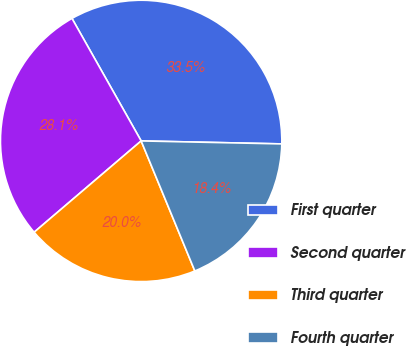Convert chart to OTSL. <chart><loc_0><loc_0><loc_500><loc_500><pie_chart><fcel>First quarter<fcel>Second quarter<fcel>Third quarter<fcel>Fourth quarter<nl><fcel>33.52%<fcel>28.06%<fcel>19.99%<fcel>18.43%<nl></chart> 